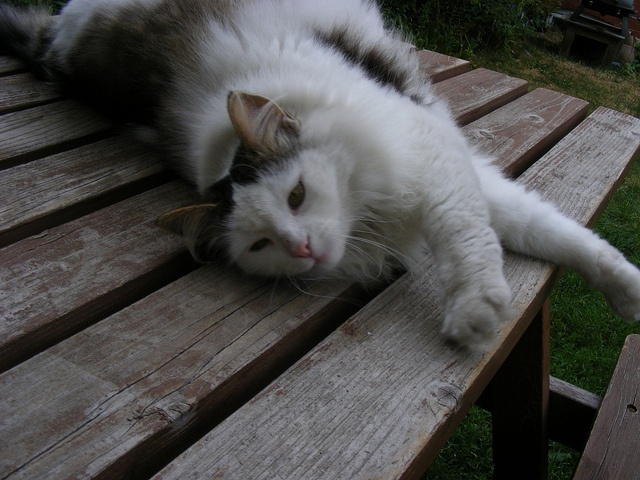Describe the objects in this image and their specific colors. I can see bench in black and gray tones and cat in black, gray, and darkgray tones in this image. 